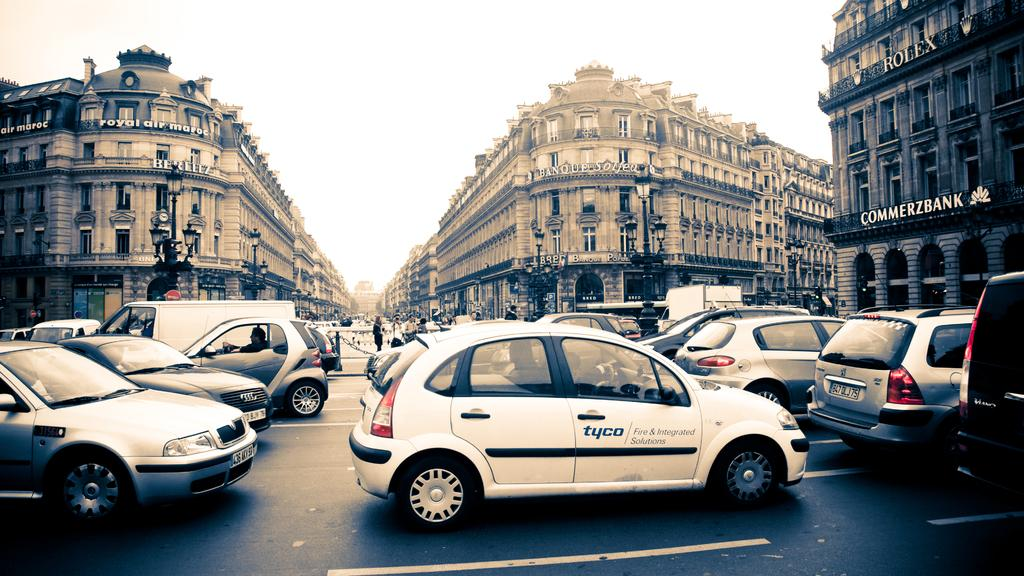<image>
Give a short and clear explanation of the subsequent image. A parking lot is full of compact cars outside a building that says Commerzbank. 